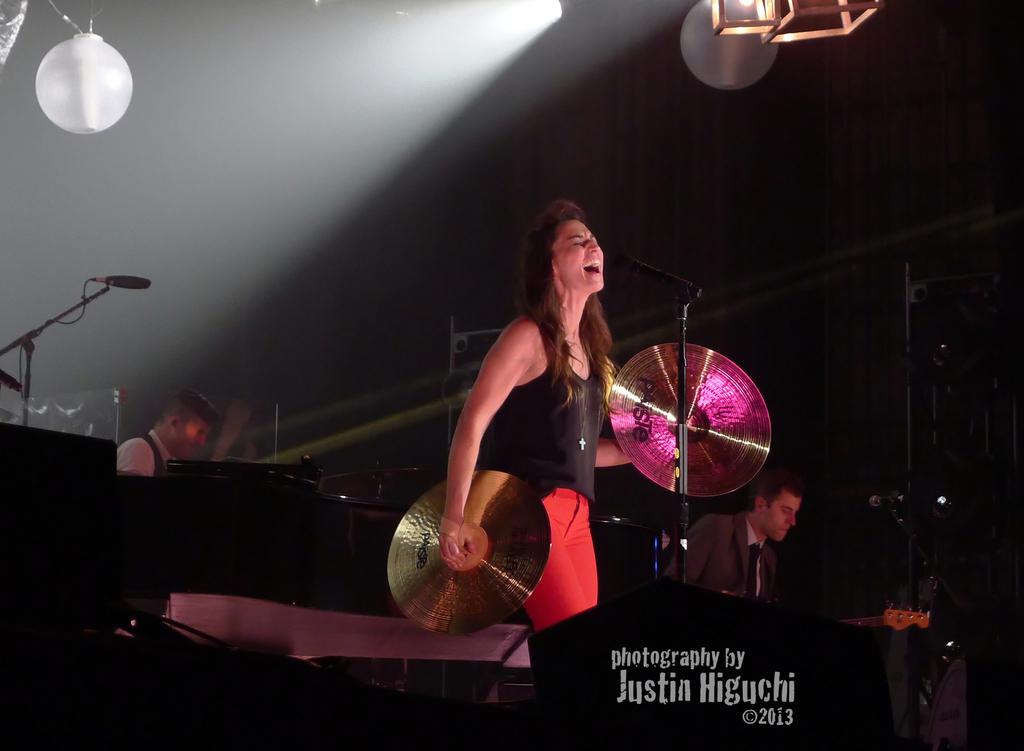What are the people in the image doing? The people in the image are playing musical instruments. How many people are playing musical instruments? There are men and a woman playing musical instruments in the image. What can be seen near the people playing instruments? There are microphones visible in the image. What information is provided at the bottom of the image? There is text at the bottom of the image. How many frogs can be seen hopping around in the image? There are no frogs present in the image. What type of noise is being made by the horse in the image? There is no horse present in the image. 